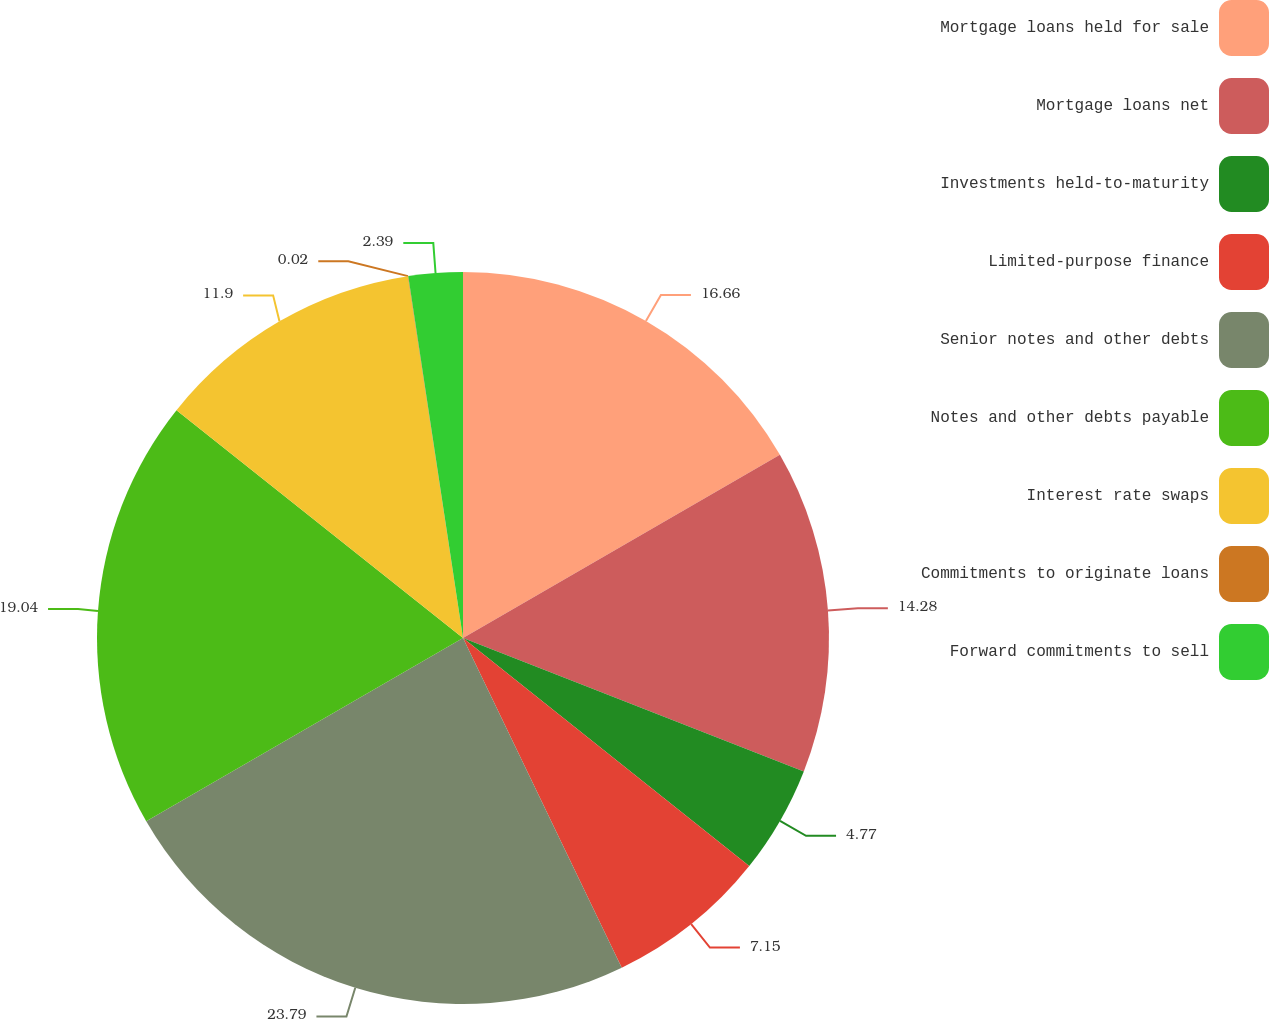Convert chart. <chart><loc_0><loc_0><loc_500><loc_500><pie_chart><fcel>Mortgage loans held for sale<fcel>Mortgage loans net<fcel>Investments held-to-maturity<fcel>Limited-purpose finance<fcel>Senior notes and other debts<fcel>Notes and other debts payable<fcel>Interest rate swaps<fcel>Commitments to originate loans<fcel>Forward commitments to sell<nl><fcel>16.66%<fcel>14.28%<fcel>4.77%<fcel>7.15%<fcel>23.79%<fcel>19.04%<fcel>11.9%<fcel>0.02%<fcel>2.39%<nl></chart> 